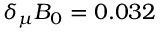Convert formula to latex. <formula><loc_0><loc_0><loc_500><loc_500>\delta _ { \mu } B _ { 0 } = 0 . 0 3 2</formula> 